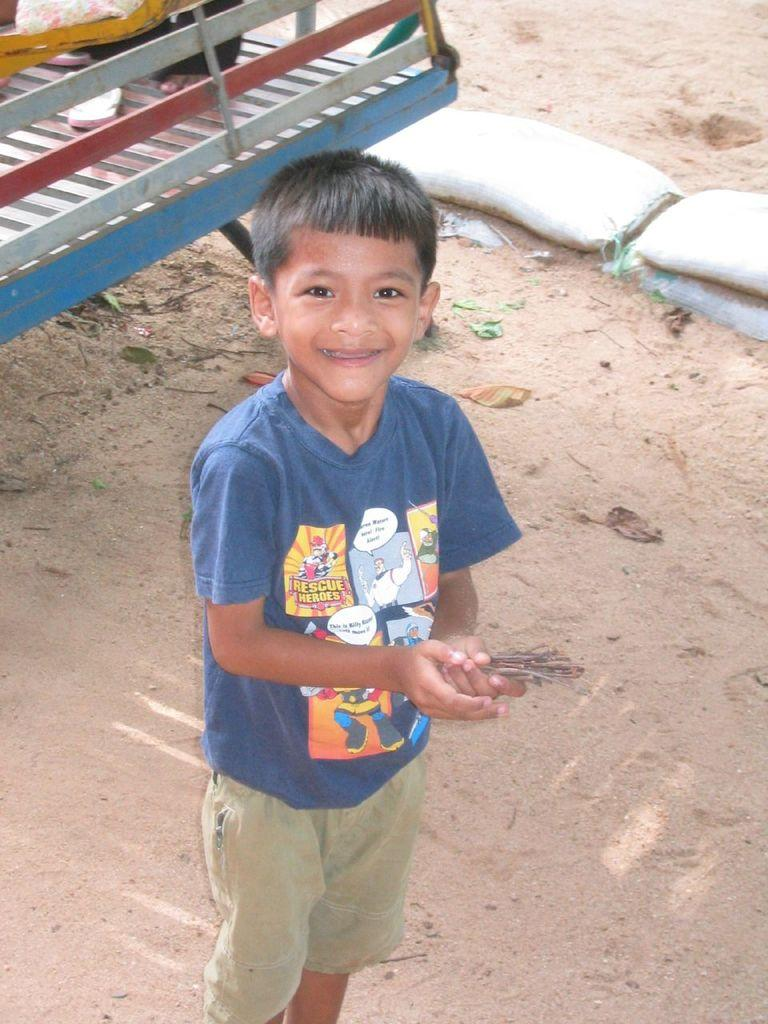Who is present in the image? There is a boy in the image. What is the boy doing in the image? The boy is standing. What is the boy wearing in the image? The boy is wearing clothes. What can be seen in the top right corner of the image? There are sandbags in the top right of the image. What type of flame can be seen on the boy's head in the image? There is no flame present on the boy's head in the image. Can you tell me how many owls are sitting on the sandbags in the image? There are no owls present in the image; only sandbags can be seen. 